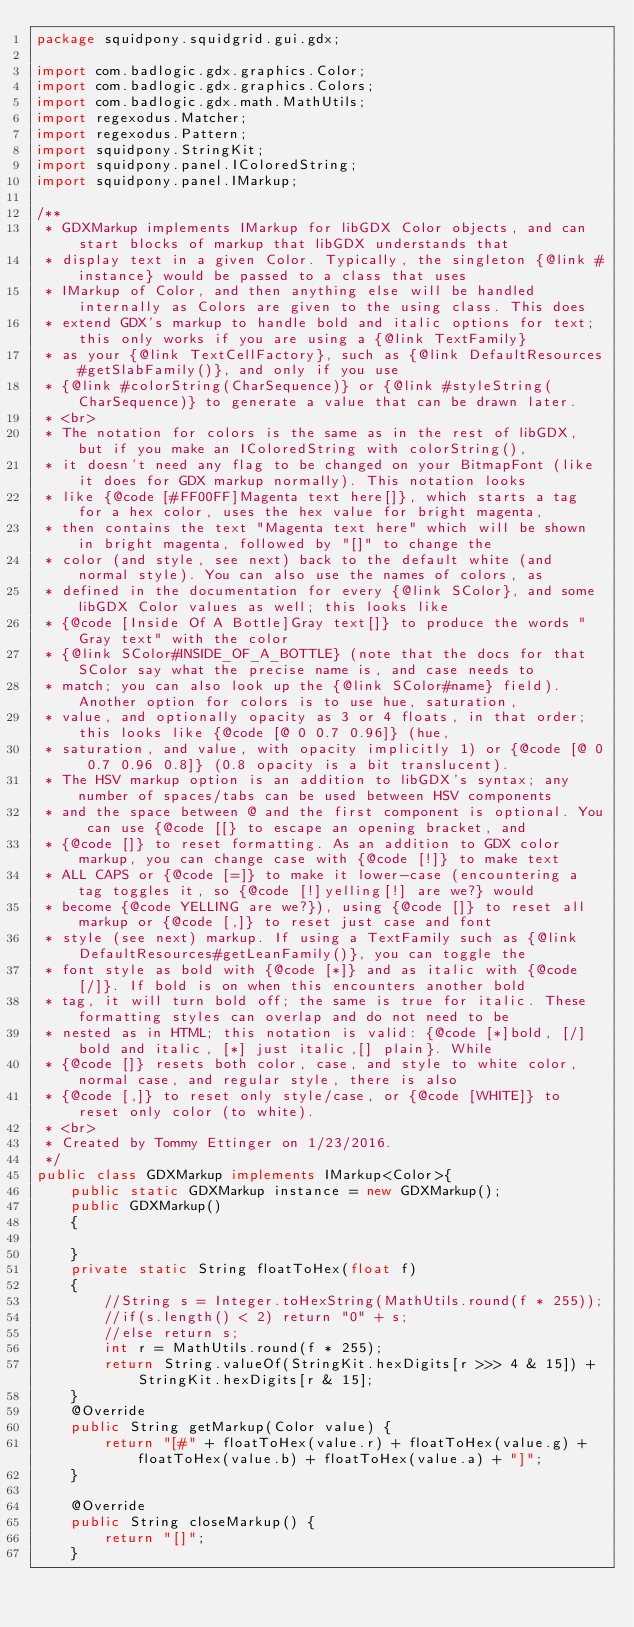<code> <loc_0><loc_0><loc_500><loc_500><_Java_>package squidpony.squidgrid.gui.gdx;

import com.badlogic.gdx.graphics.Color;
import com.badlogic.gdx.graphics.Colors;
import com.badlogic.gdx.math.MathUtils;
import regexodus.Matcher;
import regexodus.Pattern;
import squidpony.StringKit;
import squidpony.panel.IColoredString;
import squidpony.panel.IMarkup;

/**
 * GDXMarkup implements IMarkup for libGDX Color objects, and can start blocks of markup that libGDX understands that
 * display text in a given Color. Typically, the singleton {@link #instance} would be passed to a class that uses
 * IMarkup of Color, and then anything else will be handled internally as Colors are given to the using class. This does
 * extend GDX's markup to handle bold and italic options for text; this only works if you are using a {@link TextFamily}
 * as your {@link TextCellFactory}, such as {@link DefaultResources#getSlabFamily()}, and only if you use
 * {@link #colorString(CharSequence)} or {@link #styleString(CharSequence)} to generate a value that can be drawn later.
 * <br>
 * The notation for colors is the same as in the rest of libGDX, but if you make an IColoredString with colorString(),
 * it doesn't need any flag to be changed on your BitmapFont (like it does for GDX markup normally). This notation looks
 * like {@code [#FF00FF]Magenta text here[]}, which starts a tag for a hex color, uses the hex value for bright magenta,
 * then contains the text "Magenta text here" which will be shown in bright magenta, followed by "[]" to change the
 * color (and style, see next) back to the default white (and normal style). You can also use the names of colors, as
 * defined in the documentation for every {@link SColor}, and some libGDX Color values as well; this looks like
 * {@code [Inside Of A Bottle]Gray text[]} to produce the words "Gray text" with the color
 * {@link SColor#INSIDE_OF_A_BOTTLE} (note that the docs for that SColor say what the precise name is, and case needs to
 * match; you can also look up the {@link SColor#name} field). Another option for colors is to use hue, saturation,
 * value, and optionally opacity as 3 or 4 floats, in that order; this looks like {@code [@ 0 0.7 0.96]} (hue,
 * saturation, and value, with opacity implicitly 1) or {@code [@ 0 0.7 0.96 0.8]} (0.8 opacity is a bit translucent).
 * The HSV markup option is an addition to libGDX's syntax; any number of spaces/tabs can be used between HSV components
 * and the space between @ and the first component is optional. You can use {@code [[} to escape an opening bracket, and
 * {@code []} to reset formatting. As an addition to GDX color markup, you can change case with {@code [!]} to make text
 * ALL CAPS or {@code [=]} to make it lower-case (encountering a tag toggles it, so {@code [!]yelling[!] are we?} would
 * become {@code YELLING are we?}), using {@code []} to reset all markup or {@code [,]} to reset just case and font
 * style (see next) markup. If using a TextFamily such as {@link DefaultResources#getLeanFamily()}, you can toggle the
 * font style as bold with {@code [*]} and as italic with {@code [/]}. If bold is on when this encounters another bold
 * tag, it will turn bold off; the same is true for italic. These formatting styles can overlap and do not need to be
 * nested as in HTML; this notation is valid: {@code [*]bold, [/]bold and italic, [*] just italic,[] plain}. While
 * {@code []} resets both color, case, and style to white color, normal case, and regular style, there is also
 * {@code [,]} to reset only style/case, or {@code [WHITE]} to reset only color (to white).
 * <br>
 * Created by Tommy Ettinger on 1/23/2016.
 */
public class GDXMarkup implements IMarkup<Color>{
    public static GDXMarkup instance = new GDXMarkup();
    public GDXMarkup()
    {

    }
    private static String floatToHex(float f)
    {
        //String s = Integer.toHexString(MathUtils.round(f * 255));
        //if(s.length() < 2) return "0" + s;
        //else return s;
        int r = MathUtils.round(f * 255);
        return String.valueOf(StringKit.hexDigits[r >>> 4 & 15]) + StringKit.hexDigits[r & 15];
    }
    @Override
    public String getMarkup(Color value) {
        return "[#" + floatToHex(value.r) + floatToHex(value.g) + floatToHex(value.b) + floatToHex(value.a) + "]";
    }

    @Override
    public String closeMarkup() {
        return "[]";
    }
</code> 